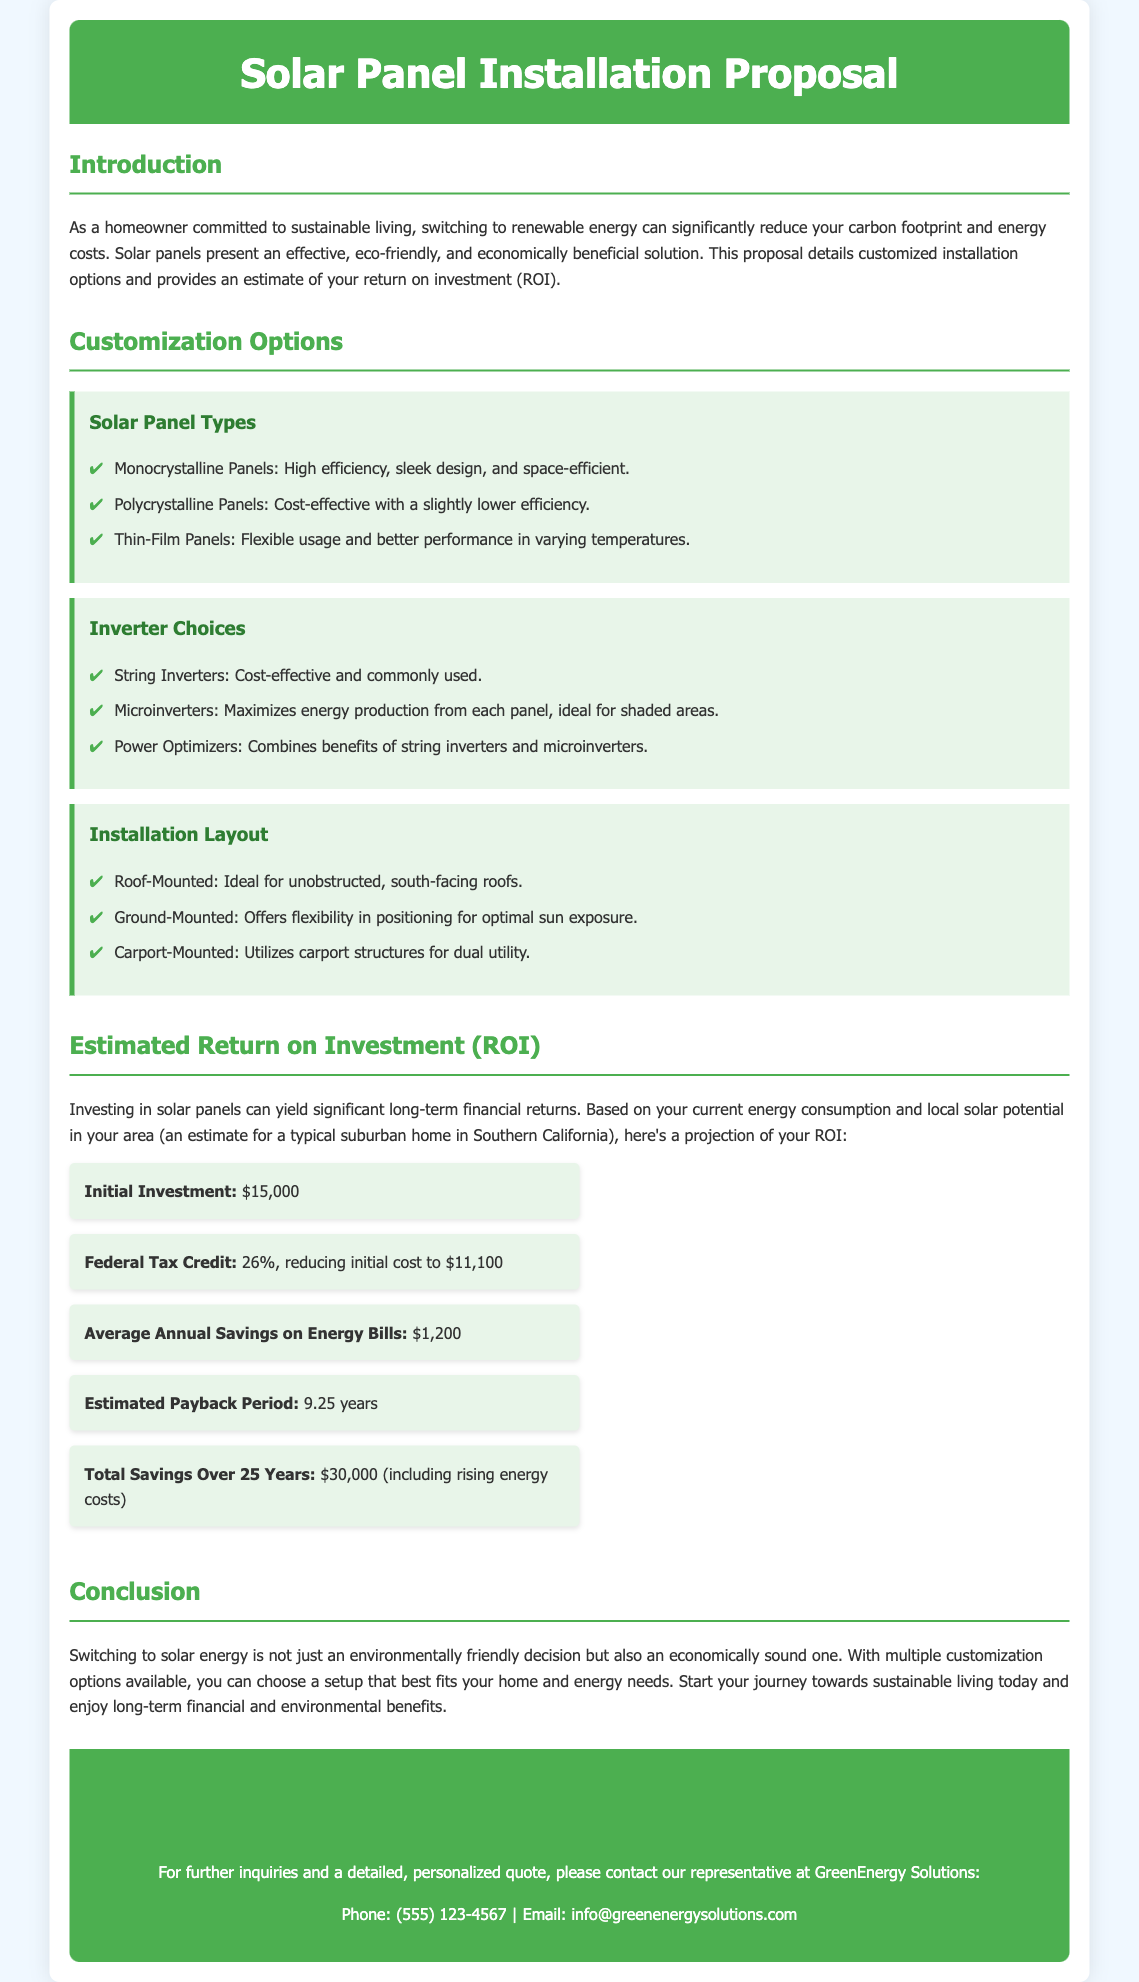what is the title of the document? The title of the document is found in the header section, which states "Solar Panel Installation Proposal."
Answer: Solar Panel Installation Proposal what is the number of customization options listed? The document lists three main customization options in the "Customization Options" section.
Answer: 3 what is the initial investment amount? The initial investment amount is stated in the "Estimated Return on Investment (ROI)" section.
Answer: $15,000 what percentage is the federal tax credit? The federal tax credit percentage is specified in the ROI details segment of the document.
Answer: 26% what is the estimated payback period? The estimated payback period is included in the ROI section and indicates how long it takes to recover the initial investment.
Answer: 9.25 years what are the types of solar panels mentioned? The types of solar panels are specified in the "Solar Panel Types" subsection under "Customization Options."
Answer: Monocrystalline, Polycrystalline, Thin-Film how much is the average annual savings on energy bills? The average annual savings figure can be found in the ROI details, detailing annual cost reductions.
Answer: $1,200 what is the total savings over 25 years? The total savings over 25 years includes considerations of rising energy costs, as stated in the ROI section.
Answer: $30,000 